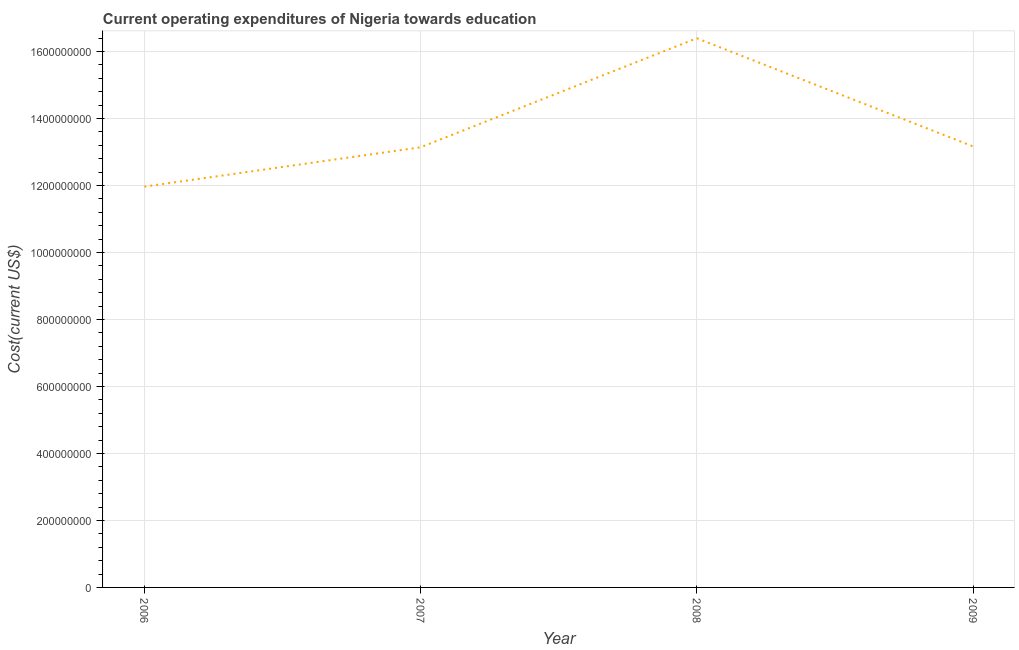What is the education expenditure in 2006?
Your answer should be very brief. 1.20e+09. Across all years, what is the maximum education expenditure?
Offer a very short reply. 1.64e+09. Across all years, what is the minimum education expenditure?
Give a very brief answer. 1.20e+09. In which year was the education expenditure maximum?
Your answer should be compact. 2008. What is the sum of the education expenditure?
Ensure brevity in your answer.  5.47e+09. What is the difference between the education expenditure in 2006 and 2008?
Provide a short and direct response. -4.43e+08. What is the average education expenditure per year?
Offer a very short reply. 1.37e+09. What is the median education expenditure?
Ensure brevity in your answer.  1.32e+09. In how many years, is the education expenditure greater than 1560000000 US$?
Keep it short and to the point. 1. Do a majority of the years between 2006 and 2008 (inclusive) have education expenditure greater than 1520000000 US$?
Provide a succinct answer. No. What is the ratio of the education expenditure in 2006 to that in 2009?
Provide a short and direct response. 0.91. What is the difference between the highest and the second highest education expenditure?
Your response must be concise. 3.23e+08. What is the difference between the highest and the lowest education expenditure?
Your answer should be very brief. 4.43e+08. Does the education expenditure monotonically increase over the years?
Offer a terse response. No. How many lines are there?
Make the answer very short. 1. How many years are there in the graph?
Your answer should be very brief. 4. What is the difference between two consecutive major ticks on the Y-axis?
Make the answer very short. 2.00e+08. Are the values on the major ticks of Y-axis written in scientific E-notation?
Provide a succinct answer. No. Does the graph contain any zero values?
Your response must be concise. No. Does the graph contain grids?
Make the answer very short. Yes. What is the title of the graph?
Provide a short and direct response. Current operating expenditures of Nigeria towards education. What is the label or title of the X-axis?
Keep it short and to the point. Year. What is the label or title of the Y-axis?
Provide a succinct answer. Cost(current US$). What is the Cost(current US$) in 2006?
Offer a very short reply. 1.20e+09. What is the Cost(current US$) of 2007?
Your answer should be compact. 1.31e+09. What is the Cost(current US$) in 2008?
Keep it short and to the point. 1.64e+09. What is the Cost(current US$) in 2009?
Provide a short and direct response. 1.32e+09. What is the difference between the Cost(current US$) in 2006 and 2007?
Your response must be concise. -1.17e+08. What is the difference between the Cost(current US$) in 2006 and 2008?
Your response must be concise. -4.43e+08. What is the difference between the Cost(current US$) in 2006 and 2009?
Ensure brevity in your answer.  -1.20e+08. What is the difference between the Cost(current US$) in 2007 and 2008?
Your answer should be very brief. -3.26e+08. What is the difference between the Cost(current US$) in 2007 and 2009?
Keep it short and to the point. -2.68e+06. What is the difference between the Cost(current US$) in 2008 and 2009?
Offer a very short reply. 3.23e+08. What is the ratio of the Cost(current US$) in 2006 to that in 2007?
Ensure brevity in your answer.  0.91. What is the ratio of the Cost(current US$) in 2006 to that in 2008?
Your answer should be compact. 0.73. What is the ratio of the Cost(current US$) in 2006 to that in 2009?
Your answer should be very brief. 0.91. What is the ratio of the Cost(current US$) in 2007 to that in 2008?
Your answer should be very brief. 0.8. What is the ratio of the Cost(current US$) in 2007 to that in 2009?
Provide a succinct answer. 1. What is the ratio of the Cost(current US$) in 2008 to that in 2009?
Your response must be concise. 1.25. 